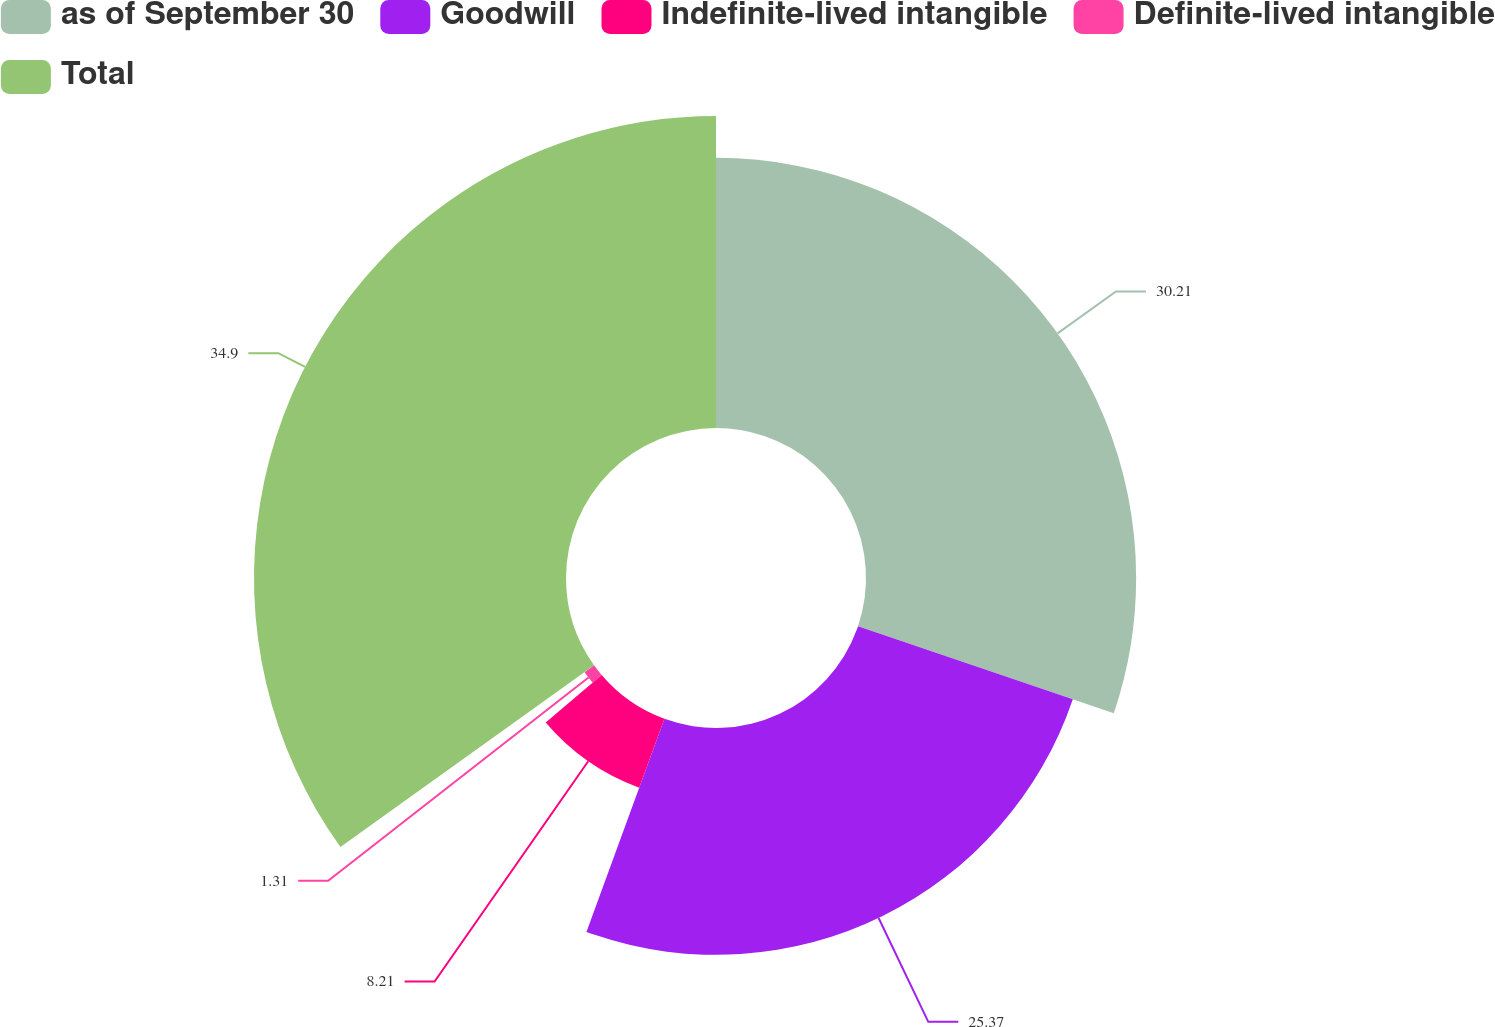Convert chart. <chart><loc_0><loc_0><loc_500><loc_500><pie_chart><fcel>as of September 30<fcel>Goodwill<fcel>Indefinite-lived intangible<fcel>Definite-lived intangible<fcel>Total<nl><fcel>30.21%<fcel>25.37%<fcel>8.21%<fcel>1.31%<fcel>34.89%<nl></chart> 